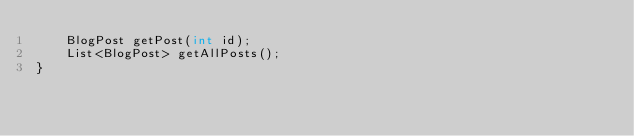<code> <loc_0><loc_0><loc_500><loc_500><_Java_>    BlogPost getPost(int id);
    List<BlogPost> getAllPosts();
}
</code> 